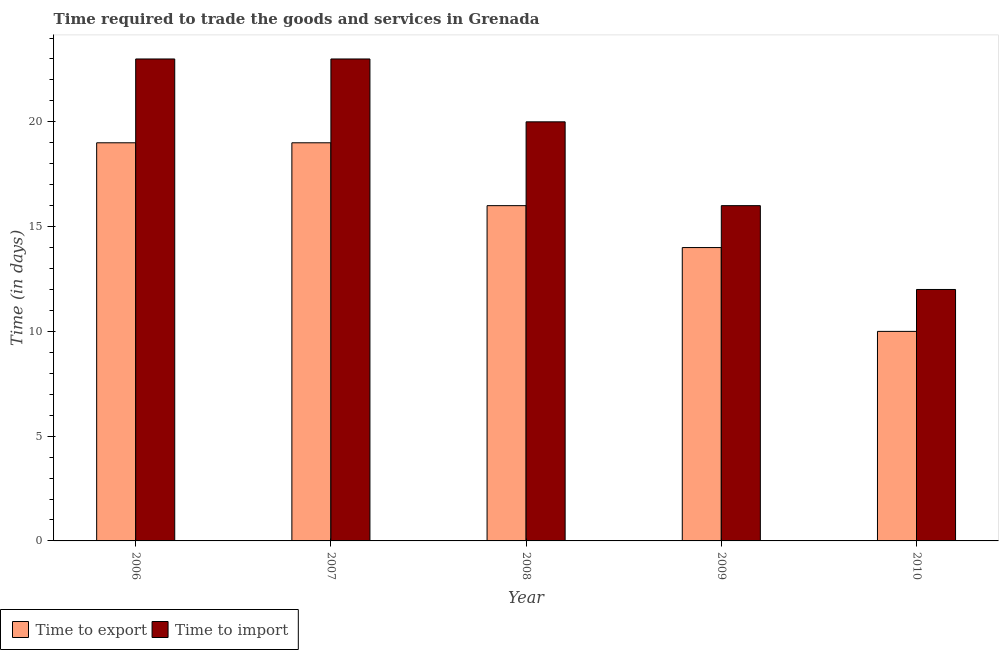Are the number of bars per tick equal to the number of legend labels?
Keep it short and to the point. Yes. How many bars are there on the 4th tick from the right?
Offer a terse response. 2. What is the time to import in 2006?
Provide a short and direct response. 23. Across all years, what is the maximum time to import?
Your answer should be compact. 23. Across all years, what is the minimum time to export?
Offer a very short reply. 10. In which year was the time to import minimum?
Provide a succinct answer. 2010. What is the total time to export in the graph?
Give a very brief answer. 78. What is the difference between the time to import in 2007 and that in 2010?
Make the answer very short. 11. What is the difference between the time to export in 2010 and the time to import in 2009?
Provide a short and direct response. -4. In how many years, is the time to export greater than 13 days?
Provide a short and direct response. 4. What is the ratio of the time to import in 2006 to that in 2009?
Provide a short and direct response. 1.44. Is the difference between the time to import in 2009 and 2010 greater than the difference between the time to export in 2009 and 2010?
Your response must be concise. No. What is the difference between the highest and the lowest time to import?
Provide a short and direct response. 11. Is the sum of the time to export in 2008 and 2009 greater than the maximum time to import across all years?
Offer a very short reply. Yes. What does the 1st bar from the left in 2008 represents?
Your answer should be very brief. Time to export. What does the 1st bar from the right in 2007 represents?
Provide a succinct answer. Time to import. Are all the bars in the graph horizontal?
Make the answer very short. No. How many years are there in the graph?
Provide a succinct answer. 5. Are the values on the major ticks of Y-axis written in scientific E-notation?
Keep it short and to the point. No. Does the graph contain grids?
Your answer should be very brief. No. Where does the legend appear in the graph?
Your answer should be very brief. Bottom left. What is the title of the graph?
Offer a very short reply. Time required to trade the goods and services in Grenada. Does "Personal remittances" appear as one of the legend labels in the graph?
Give a very brief answer. No. What is the label or title of the Y-axis?
Offer a terse response. Time (in days). What is the Time (in days) in Time to import in 2006?
Make the answer very short. 23. What is the Time (in days) of Time to import in 2007?
Keep it short and to the point. 23. What is the Time (in days) in Time to export in 2008?
Keep it short and to the point. 16. What is the Time (in days) of Time to import in 2009?
Offer a very short reply. 16. What is the Time (in days) of Time to export in 2010?
Offer a very short reply. 10. Across all years, what is the minimum Time (in days) of Time to import?
Offer a very short reply. 12. What is the total Time (in days) of Time to export in the graph?
Provide a succinct answer. 78. What is the total Time (in days) of Time to import in the graph?
Ensure brevity in your answer.  94. What is the difference between the Time (in days) in Time to import in 2006 and that in 2007?
Your answer should be compact. 0. What is the difference between the Time (in days) in Time to import in 2006 and that in 2008?
Provide a succinct answer. 3. What is the difference between the Time (in days) of Time to import in 2006 and that in 2009?
Your answer should be compact. 7. What is the difference between the Time (in days) in Time to export in 2007 and that in 2008?
Offer a very short reply. 3. What is the difference between the Time (in days) of Time to export in 2007 and that in 2009?
Offer a very short reply. 5. What is the difference between the Time (in days) of Time to import in 2007 and that in 2010?
Make the answer very short. 11. What is the difference between the Time (in days) of Time to import in 2008 and that in 2009?
Ensure brevity in your answer.  4. What is the difference between the Time (in days) in Time to export in 2009 and that in 2010?
Make the answer very short. 4. What is the difference between the Time (in days) of Time to import in 2009 and that in 2010?
Provide a succinct answer. 4. What is the difference between the Time (in days) of Time to export in 2006 and the Time (in days) of Time to import in 2010?
Offer a very short reply. 7. What is the difference between the Time (in days) of Time to export in 2007 and the Time (in days) of Time to import in 2008?
Your answer should be compact. -1. What is the difference between the Time (in days) of Time to export in 2009 and the Time (in days) of Time to import in 2010?
Ensure brevity in your answer.  2. What is the average Time (in days) in Time to export per year?
Give a very brief answer. 15.6. In the year 2006, what is the difference between the Time (in days) of Time to export and Time (in days) of Time to import?
Provide a succinct answer. -4. In the year 2007, what is the difference between the Time (in days) in Time to export and Time (in days) in Time to import?
Offer a very short reply. -4. In the year 2009, what is the difference between the Time (in days) of Time to export and Time (in days) of Time to import?
Your answer should be compact. -2. In the year 2010, what is the difference between the Time (in days) of Time to export and Time (in days) of Time to import?
Keep it short and to the point. -2. What is the ratio of the Time (in days) of Time to export in 2006 to that in 2008?
Give a very brief answer. 1.19. What is the ratio of the Time (in days) in Time to import in 2006 to that in 2008?
Your answer should be very brief. 1.15. What is the ratio of the Time (in days) of Time to export in 2006 to that in 2009?
Offer a very short reply. 1.36. What is the ratio of the Time (in days) in Time to import in 2006 to that in 2009?
Keep it short and to the point. 1.44. What is the ratio of the Time (in days) of Time to export in 2006 to that in 2010?
Your answer should be compact. 1.9. What is the ratio of the Time (in days) in Time to import in 2006 to that in 2010?
Your answer should be compact. 1.92. What is the ratio of the Time (in days) in Time to export in 2007 to that in 2008?
Your response must be concise. 1.19. What is the ratio of the Time (in days) of Time to import in 2007 to that in 2008?
Offer a very short reply. 1.15. What is the ratio of the Time (in days) of Time to export in 2007 to that in 2009?
Make the answer very short. 1.36. What is the ratio of the Time (in days) in Time to import in 2007 to that in 2009?
Make the answer very short. 1.44. What is the ratio of the Time (in days) in Time to import in 2007 to that in 2010?
Offer a terse response. 1.92. What is the ratio of the Time (in days) of Time to export in 2008 to that in 2009?
Provide a short and direct response. 1.14. What is the ratio of the Time (in days) of Time to import in 2008 to that in 2009?
Give a very brief answer. 1.25. What is the ratio of the Time (in days) of Time to import in 2008 to that in 2010?
Your response must be concise. 1.67. What is the difference between the highest and the lowest Time (in days) in Time to export?
Make the answer very short. 9. 